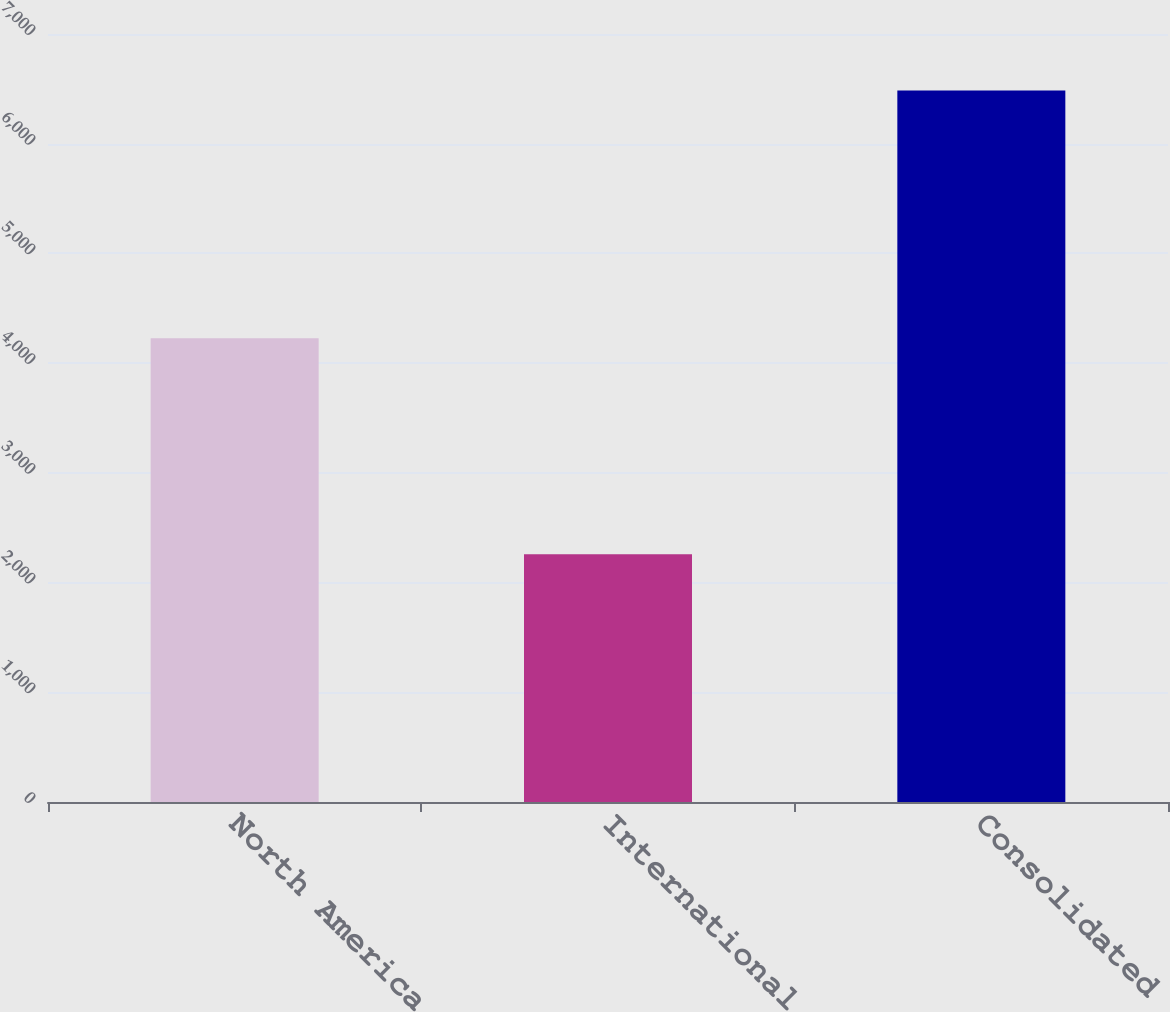Convert chart. <chart><loc_0><loc_0><loc_500><loc_500><bar_chart><fcel>North America<fcel>International<fcel>Consolidated<nl><fcel>4227<fcel>2258<fcel>6485<nl></chart> 